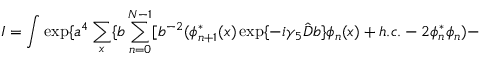<formula> <loc_0><loc_0><loc_500><loc_500>I = \int \exp \{ a ^ { 4 } \sum _ { x } \{ b \sum _ { n = 0 } ^ { N - 1 } [ b ^ { - 2 } ( \phi _ { n + 1 } ^ { * } ( x ) \exp \{ - i \gamma _ { 5 } \hat { D } b \} \phi _ { n } ( x ) + h . c . - 2 \phi _ { n } ^ { * } \phi _ { n } ) -</formula> 